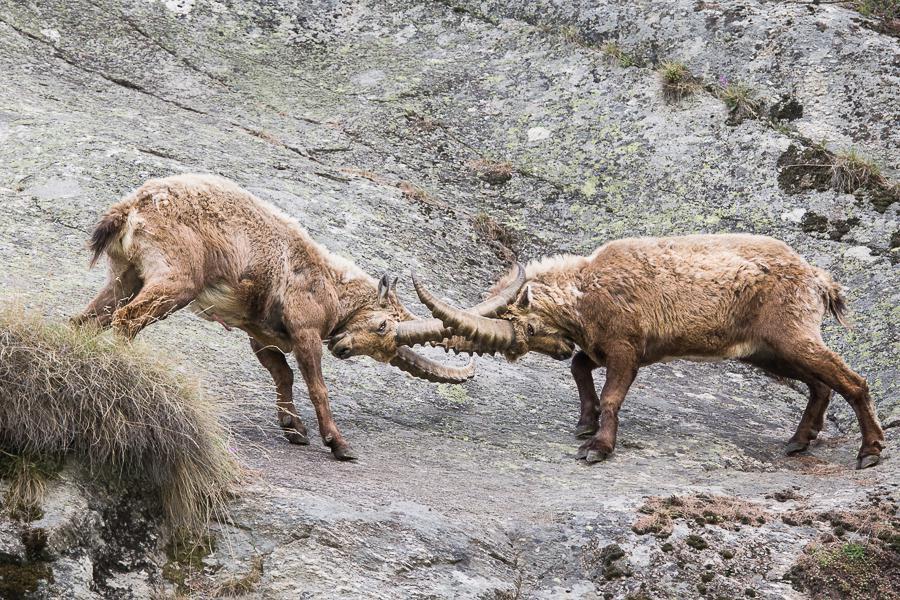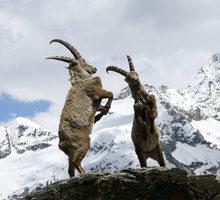The first image is the image on the left, the second image is the image on the right. Analyze the images presented: Is the assertion "Left image shows one horned animal standing with its body turned rightward." valid? Answer yes or no. No. 